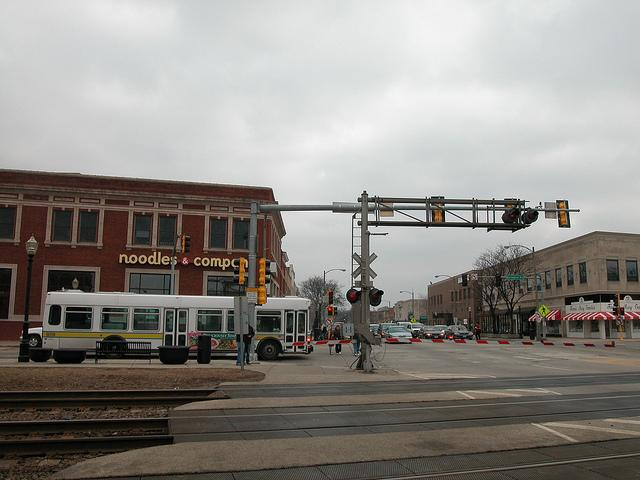What is causing traffic to stop?

Choices:
A) pedestrians
B) stalled car
C) oncoming train
D) stalled bus oncoming train 